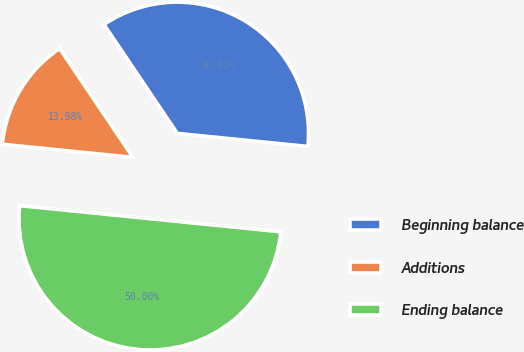Convert chart to OTSL. <chart><loc_0><loc_0><loc_500><loc_500><pie_chart><fcel>Beginning balance<fcel>Additions<fcel>Ending balance<nl><fcel>36.02%<fcel>13.98%<fcel>50.0%<nl></chart> 